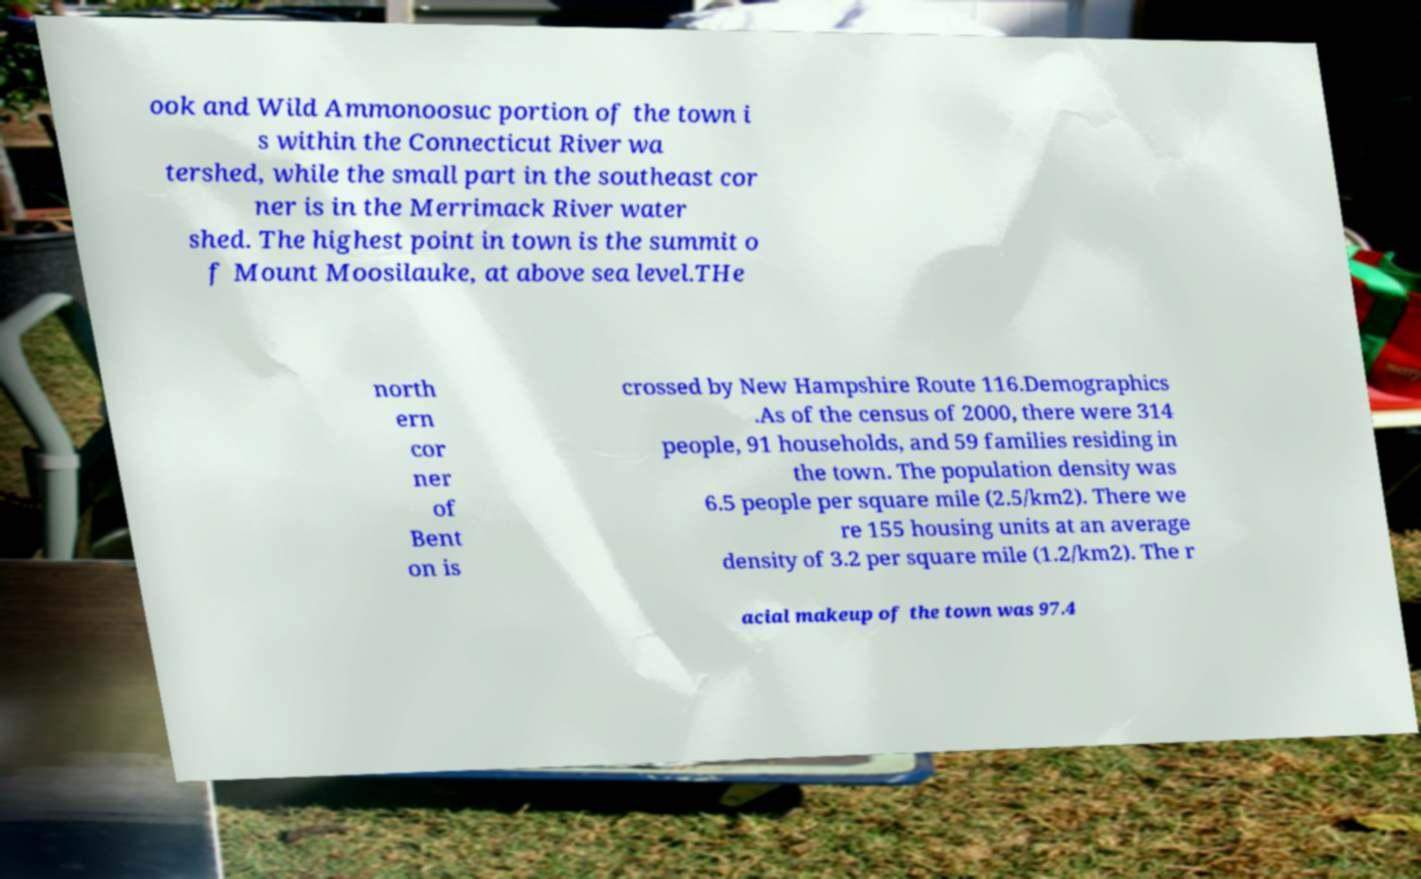Could you extract and type out the text from this image? ook and Wild Ammonoosuc portion of the town i s within the Connecticut River wa tershed, while the small part in the southeast cor ner is in the Merrimack River water shed. The highest point in town is the summit o f Mount Moosilauke, at above sea level.THe north ern cor ner of Bent on is crossed by New Hampshire Route 116.Demographics .As of the census of 2000, there were 314 people, 91 households, and 59 families residing in the town. The population density was 6.5 people per square mile (2.5/km2). There we re 155 housing units at an average density of 3.2 per square mile (1.2/km2). The r acial makeup of the town was 97.4 